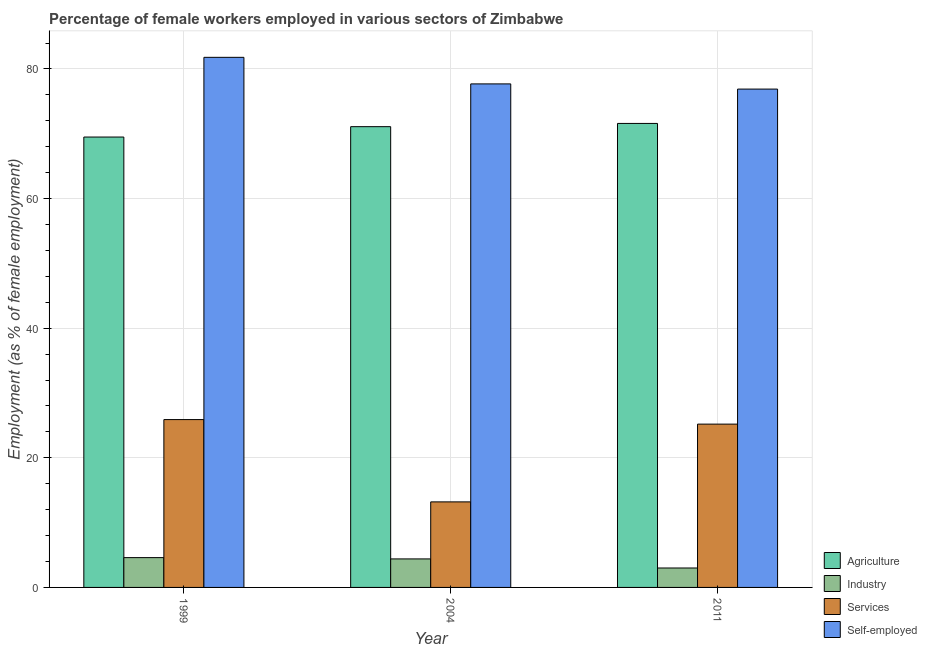How many bars are there on the 1st tick from the left?
Provide a short and direct response. 4. How many bars are there on the 3rd tick from the right?
Your answer should be compact. 4. What is the label of the 1st group of bars from the left?
Offer a terse response. 1999. Across all years, what is the maximum percentage of female workers in services?
Give a very brief answer. 25.9. In which year was the percentage of female workers in agriculture maximum?
Offer a very short reply. 2011. In which year was the percentage of self employed female workers minimum?
Provide a short and direct response. 2011. What is the total percentage of female workers in services in the graph?
Give a very brief answer. 64.3. What is the difference between the percentage of female workers in industry in 2004 and that in 2011?
Give a very brief answer. 1.4. What is the difference between the percentage of female workers in agriculture in 2004 and the percentage of female workers in industry in 2011?
Give a very brief answer. -0.5. What is the average percentage of self employed female workers per year?
Provide a short and direct response. 78.8. In how many years, is the percentage of self employed female workers greater than 20 %?
Provide a short and direct response. 3. What is the ratio of the percentage of female workers in agriculture in 2004 to that in 2011?
Provide a short and direct response. 0.99. What is the difference between the highest and the second highest percentage of female workers in industry?
Offer a terse response. 0.2. What is the difference between the highest and the lowest percentage of female workers in agriculture?
Offer a very short reply. 2.1. In how many years, is the percentage of self employed female workers greater than the average percentage of self employed female workers taken over all years?
Provide a short and direct response. 1. What does the 2nd bar from the left in 1999 represents?
Make the answer very short. Industry. What does the 1st bar from the right in 2004 represents?
Ensure brevity in your answer.  Self-employed. How many years are there in the graph?
Offer a terse response. 3. What is the difference between two consecutive major ticks on the Y-axis?
Your response must be concise. 20. Does the graph contain grids?
Keep it short and to the point. Yes. What is the title of the graph?
Keep it short and to the point. Percentage of female workers employed in various sectors of Zimbabwe. What is the label or title of the X-axis?
Provide a short and direct response. Year. What is the label or title of the Y-axis?
Your response must be concise. Employment (as % of female employment). What is the Employment (as % of female employment) of Agriculture in 1999?
Your response must be concise. 69.5. What is the Employment (as % of female employment) in Industry in 1999?
Provide a short and direct response. 4.6. What is the Employment (as % of female employment) in Services in 1999?
Give a very brief answer. 25.9. What is the Employment (as % of female employment) in Self-employed in 1999?
Offer a very short reply. 81.8. What is the Employment (as % of female employment) in Agriculture in 2004?
Provide a succinct answer. 71.1. What is the Employment (as % of female employment) of Industry in 2004?
Give a very brief answer. 4.4. What is the Employment (as % of female employment) in Services in 2004?
Your answer should be very brief. 13.2. What is the Employment (as % of female employment) of Self-employed in 2004?
Provide a succinct answer. 77.7. What is the Employment (as % of female employment) of Agriculture in 2011?
Keep it short and to the point. 71.6. What is the Employment (as % of female employment) in Industry in 2011?
Offer a very short reply. 3. What is the Employment (as % of female employment) in Services in 2011?
Ensure brevity in your answer.  25.2. What is the Employment (as % of female employment) of Self-employed in 2011?
Your answer should be compact. 76.9. Across all years, what is the maximum Employment (as % of female employment) of Agriculture?
Your response must be concise. 71.6. Across all years, what is the maximum Employment (as % of female employment) in Industry?
Provide a short and direct response. 4.6. Across all years, what is the maximum Employment (as % of female employment) in Services?
Your answer should be compact. 25.9. Across all years, what is the maximum Employment (as % of female employment) of Self-employed?
Provide a short and direct response. 81.8. Across all years, what is the minimum Employment (as % of female employment) of Agriculture?
Your response must be concise. 69.5. Across all years, what is the minimum Employment (as % of female employment) of Services?
Provide a short and direct response. 13.2. Across all years, what is the minimum Employment (as % of female employment) in Self-employed?
Offer a very short reply. 76.9. What is the total Employment (as % of female employment) in Agriculture in the graph?
Provide a short and direct response. 212.2. What is the total Employment (as % of female employment) in Services in the graph?
Ensure brevity in your answer.  64.3. What is the total Employment (as % of female employment) of Self-employed in the graph?
Make the answer very short. 236.4. What is the difference between the Employment (as % of female employment) in Agriculture in 1999 and that in 2004?
Keep it short and to the point. -1.6. What is the difference between the Employment (as % of female employment) in Industry in 1999 and that in 2004?
Your answer should be very brief. 0.2. What is the difference between the Employment (as % of female employment) in Services in 1999 and that in 2004?
Offer a terse response. 12.7. What is the difference between the Employment (as % of female employment) in Agriculture in 2004 and that in 2011?
Give a very brief answer. -0.5. What is the difference between the Employment (as % of female employment) in Industry in 2004 and that in 2011?
Your answer should be very brief. 1.4. What is the difference between the Employment (as % of female employment) in Agriculture in 1999 and the Employment (as % of female employment) in Industry in 2004?
Provide a short and direct response. 65.1. What is the difference between the Employment (as % of female employment) of Agriculture in 1999 and the Employment (as % of female employment) of Services in 2004?
Provide a succinct answer. 56.3. What is the difference between the Employment (as % of female employment) of Industry in 1999 and the Employment (as % of female employment) of Self-employed in 2004?
Your response must be concise. -73.1. What is the difference between the Employment (as % of female employment) in Services in 1999 and the Employment (as % of female employment) in Self-employed in 2004?
Your response must be concise. -51.8. What is the difference between the Employment (as % of female employment) of Agriculture in 1999 and the Employment (as % of female employment) of Industry in 2011?
Your answer should be very brief. 66.5. What is the difference between the Employment (as % of female employment) of Agriculture in 1999 and the Employment (as % of female employment) of Services in 2011?
Your response must be concise. 44.3. What is the difference between the Employment (as % of female employment) of Agriculture in 1999 and the Employment (as % of female employment) of Self-employed in 2011?
Make the answer very short. -7.4. What is the difference between the Employment (as % of female employment) in Industry in 1999 and the Employment (as % of female employment) in Services in 2011?
Ensure brevity in your answer.  -20.6. What is the difference between the Employment (as % of female employment) in Industry in 1999 and the Employment (as % of female employment) in Self-employed in 2011?
Your answer should be very brief. -72.3. What is the difference between the Employment (as % of female employment) of Services in 1999 and the Employment (as % of female employment) of Self-employed in 2011?
Provide a succinct answer. -51. What is the difference between the Employment (as % of female employment) of Agriculture in 2004 and the Employment (as % of female employment) of Industry in 2011?
Your response must be concise. 68.1. What is the difference between the Employment (as % of female employment) of Agriculture in 2004 and the Employment (as % of female employment) of Services in 2011?
Your answer should be very brief. 45.9. What is the difference between the Employment (as % of female employment) in Agriculture in 2004 and the Employment (as % of female employment) in Self-employed in 2011?
Keep it short and to the point. -5.8. What is the difference between the Employment (as % of female employment) of Industry in 2004 and the Employment (as % of female employment) of Services in 2011?
Provide a succinct answer. -20.8. What is the difference between the Employment (as % of female employment) in Industry in 2004 and the Employment (as % of female employment) in Self-employed in 2011?
Offer a terse response. -72.5. What is the difference between the Employment (as % of female employment) in Services in 2004 and the Employment (as % of female employment) in Self-employed in 2011?
Provide a succinct answer. -63.7. What is the average Employment (as % of female employment) in Agriculture per year?
Keep it short and to the point. 70.73. What is the average Employment (as % of female employment) of Industry per year?
Give a very brief answer. 4. What is the average Employment (as % of female employment) in Services per year?
Ensure brevity in your answer.  21.43. What is the average Employment (as % of female employment) of Self-employed per year?
Ensure brevity in your answer.  78.8. In the year 1999, what is the difference between the Employment (as % of female employment) in Agriculture and Employment (as % of female employment) in Industry?
Your answer should be compact. 64.9. In the year 1999, what is the difference between the Employment (as % of female employment) of Agriculture and Employment (as % of female employment) of Services?
Provide a short and direct response. 43.6. In the year 1999, what is the difference between the Employment (as % of female employment) in Agriculture and Employment (as % of female employment) in Self-employed?
Give a very brief answer. -12.3. In the year 1999, what is the difference between the Employment (as % of female employment) of Industry and Employment (as % of female employment) of Services?
Your response must be concise. -21.3. In the year 1999, what is the difference between the Employment (as % of female employment) of Industry and Employment (as % of female employment) of Self-employed?
Ensure brevity in your answer.  -77.2. In the year 1999, what is the difference between the Employment (as % of female employment) in Services and Employment (as % of female employment) in Self-employed?
Ensure brevity in your answer.  -55.9. In the year 2004, what is the difference between the Employment (as % of female employment) in Agriculture and Employment (as % of female employment) in Industry?
Make the answer very short. 66.7. In the year 2004, what is the difference between the Employment (as % of female employment) in Agriculture and Employment (as % of female employment) in Services?
Offer a terse response. 57.9. In the year 2004, what is the difference between the Employment (as % of female employment) of Agriculture and Employment (as % of female employment) of Self-employed?
Keep it short and to the point. -6.6. In the year 2004, what is the difference between the Employment (as % of female employment) of Industry and Employment (as % of female employment) of Services?
Provide a succinct answer. -8.8. In the year 2004, what is the difference between the Employment (as % of female employment) of Industry and Employment (as % of female employment) of Self-employed?
Keep it short and to the point. -73.3. In the year 2004, what is the difference between the Employment (as % of female employment) of Services and Employment (as % of female employment) of Self-employed?
Ensure brevity in your answer.  -64.5. In the year 2011, what is the difference between the Employment (as % of female employment) in Agriculture and Employment (as % of female employment) in Industry?
Keep it short and to the point. 68.6. In the year 2011, what is the difference between the Employment (as % of female employment) in Agriculture and Employment (as % of female employment) in Services?
Ensure brevity in your answer.  46.4. In the year 2011, what is the difference between the Employment (as % of female employment) of Industry and Employment (as % of female employment) of Services?
Provide a short and direct response. -22.2. In the year 2011, what is the difference between the Employment (as % of female employment) of Industry and Employment (as % of female employment) of Self-employed?
Provide a short and direct response. -73.9. In the year 2011, what is the difference between the Employment (as % of female employment) in Services and Employment (as % of female employment) in Self-employed?
Provide a succinct answer. -51.7. What is the ratio of the Employment (as % of female employment) of Agriculture in 1999 to that in 2004?
Provide a succinct answer. 0.98. What is the ratio of the Employment (as % of female employment) of Industry in 1999 to that in 2004?
Give a very brief answer. 1.05. What is the ratio of the Employment (as % of female employment) in Services in 1999 to that in 2004?
Provide a succinct answer. 1.96. What is the ratio of the Employment (as % of female employment) of Self-employed in 1999 to that in 2004?
Offer a very short reply. 1.05. What is the ratio of the Employment (as % of female employment) in Agriculture in 1999 to that in 2011?
Ensure brevity in your answer.  0.97. What is the ratio of the Employment (as % of female employment) of Industry in 1999 to that in 2011?
Provide a succinct answer. 1.53. What is the ratio of the Employment (as % of female employment) of Services in 1999 to that in 2011?
Give a very brief answer. 1.03. What is the ratio of the Employment (as % of female employment) of Self-employed in 1999 to that in 2011?
Offer a terse response. 1.06. What is the ratio of the Employment (as % of female employment) in Agriculture in 2004 to that in 2011?
Your response must be concise. 0.99. What is the ratio of the Employment (as % of female employment) in Industry in 2004 to that in 2011?
Provide a short and direct response. 1.47. What is the ratio of the Employment (as % of female employment) in Services in 2004 to that in 2011?
Give a very brief answer. 0.52. What is the ratio of the Employment (as % of female employment) of Self-employed in 2004 to that in 2011?
Your answer should be very brief. 1.01. What is the difference between the highest and the second highest Employment (as % of female employment) in Self-employed?
Your response must be concise. 4.1. What is the difference between the highest and the lowest Employment (as % of female employment) of Agriculture?
Your answer should be compact. 2.1. What is the difference between the highest and the lowest Employment (as % of female employment) of Industry?
Make the answer very short. 1.6. 